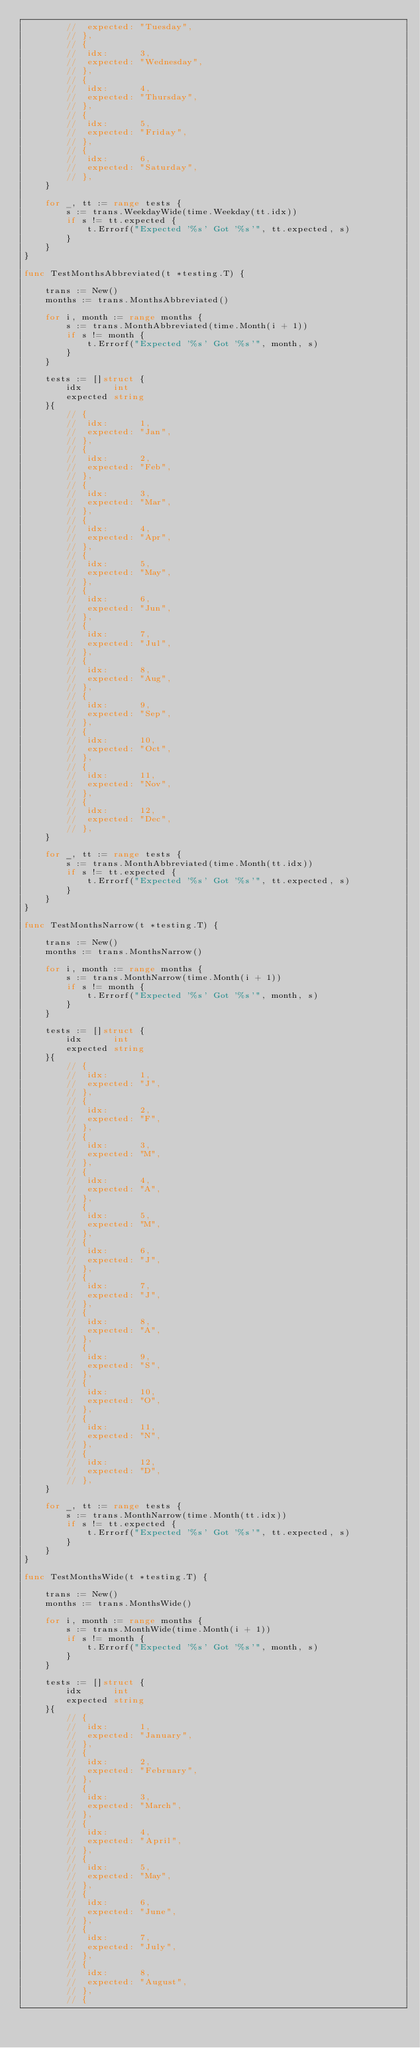<code> <loc_0><loc_0><loc_500><loc_500><_Go_>		// 	expected: "Tuesday",
		// },
		// {
		// 	idx:      3,
		// 	expected: "Wednesday",
		// },
		// {
		// 	idx:      4,
		// 	expected: "Thursday",
		// },
		// {
		// 	idx:      5,
		// 	expected: "Friday",
		// },
		// {
		// 	idx:      6,
		// 	expected: "Saturday",
		// },
	}

	for _, tt := range tests {
		s := trans.WeekdayWide(time.Weekday(tt.idx))
		if s != tt.expected {
			t.Errorf("Expected '%s' Got '%s'", tt.expected, s)
		}
	}
}

func TestMonthsAbbreviated(t *testing.T) {

	trans := New()
	months := trans.MonthsAbbreviated()

	for i, month := range months {
		s := trans.MonthAbbreviated(time.Month(i + 1))
		if s != month {
			t.Errorf("Expected '%s' Got '%s'", month, s)
		}
	}

	tests := []struct {
		idx      int
		expected string
	}{
		// {
		// 	idx:      1,
		// 	expected: "Jan",
		// },
		// {
		// 	idx:      2,
		// 	expected: "Feb",
		// },
		// {
		// 	idx:      3,
		// 	expected: "Mar",
		// },
		// {
		// 	idx:      4,
		// 	expected: "Apr",
		// },
		// {
		// 	idx:      5,
		// 	expected: "May",
		// },
		// {
		// 	idx:      6,
		// 	expected: "Jun",
		// },
		// {
		// 	idx:      7,
		// 	expected: "Jul",
		// },
		// {
		// 	idx:      8,
		// 	expected: "Aug",
		// },
		// {
		// 	idx:      9,
		// 	expected: "Sep",
		// },
		// {
		// 	idx:      10,
		// 	expected: "Oct",
		// },
		// {
		// 	idx:      11,
		// 	expected: "Nov",
		// },
		// {
		// 	idx:      12,
		// 	expected: "Dec",
		// },
	}

	for _, tt := range tests {
		s := trans.MonthAbbreviated(time.Month(tt.idx))
		if s != tt.expected {
			t.Errorf("Expected '%s' Got '%s'", tt.expected, s)
		}
	}
}

func TestMonthsNarrow(t *testing.T) {

	trans := New()
	months := trans.MonthsNarrow()

	for i, month := range months {
		s := trans.MonthNarrow(time.Month(i + 1))
		if s != month {
			t.Errorf("Expected '%s' Got '%s'", month, s)
		}
	}

	tests := []struct {
		idx      int
		expected string
	}{
		// {
		// 	idx:      1,
		// 	expected: "J",
		// },
		// {
		// 	idx:      2,
		// 	expected: "F",
		// },
		// {
		// 	idx:      3,
		// 	expected: "M",
		// },
		// {
		// 	idx:      4,
		// 	expected: "A",
		// },
		// {
		// 	idx:      5,
		// 	expected: "M",
		// },
		// {
		// 	idx:      6,
		// 	expected: "J",
		// },
		// {
		// 	idx:      7,
		// 	expected: "J",
		// },
		// {
		// 	idx:      8,
		// 	expected: "A",
		// },
		// {
		// 	idx:      9,
		// 	expected: "S",
		// },
		// {
		// 	idx:      10,
		// 	expected: "O",
		// },
		// {
		// 	idx:      11,
		// 	expected: "N",
		// },
		// {
		// 	idx:      12,
		// 	expected: "D",
		// },
	}

	for _, tt := range tests {
		s := trans.MonthNarrow(time.Month(tt.idx))
		if s != tt.expected {
			t.Errorf("Expected '%s' Got '%s'", tt.expected, s)
		}
	}
}

func TestMonthsWide(t *testing.T) {

	trans := New()
	months := trans.MonthsWide()

	for i, month := range months {
		s := trans.MonthWide(time.Month(i + 1))
		if s != month {
			t.Errorf("Expected '%s' Got '%s'", month, s)
		}
	}

	tests := []struct {
		idx      int
		expected string
	}{
		// {
		// 	idx:      1,
		// 	expected: "January",
		// },
		// {
		// 	idx:      2,
		// 	expected: "February",
		// },
		// {
		// 	idx:      3,
		// 	expected: "March",
		// },
		// {
		// 	idx:      4,
		// 	expected: "April",
		// },
		// {
		// 	idx:      5,
		// 	expected: "May",
		// },
		// {
		// 	idx:      6,
		// 	expected: "June",
		// },
		// {
		// 	idx:      7,
		// 	expected: "July",
		// },
		// {
		// 	idx:      8,
		// 	expected: "August",
		// },
		// {</code> 